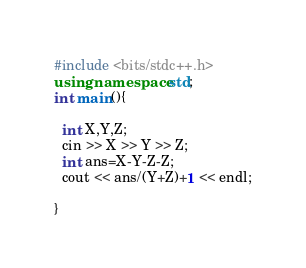<code> <loc_0><loc_0><loc_500><loc_500><_C++_>#include <bits/stdc++.h>
using namespace std;
int main(){
  
  int X,Y,Z;
  cin >> X >> Y >> Z;
  int ans=X-Y-Z-Z;
  cout << ans/(Y+Z)+1 << endl;
  
}
</code> 